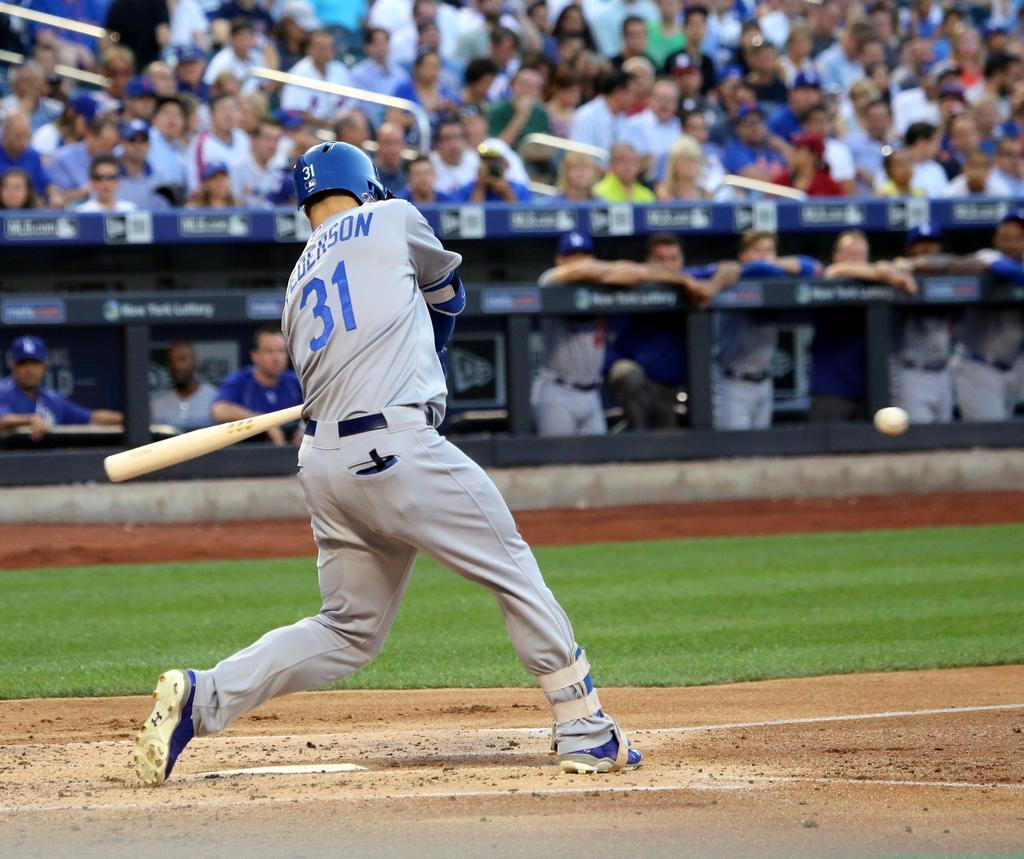Could you give a brief overview of what you see in this image? This image consists of a man wearing a helmet. He is holding a baseball bat. At the bottom, there is green grass on the ground. In the background, we can see a huge crowd. At the bottom, there is a fencing. 